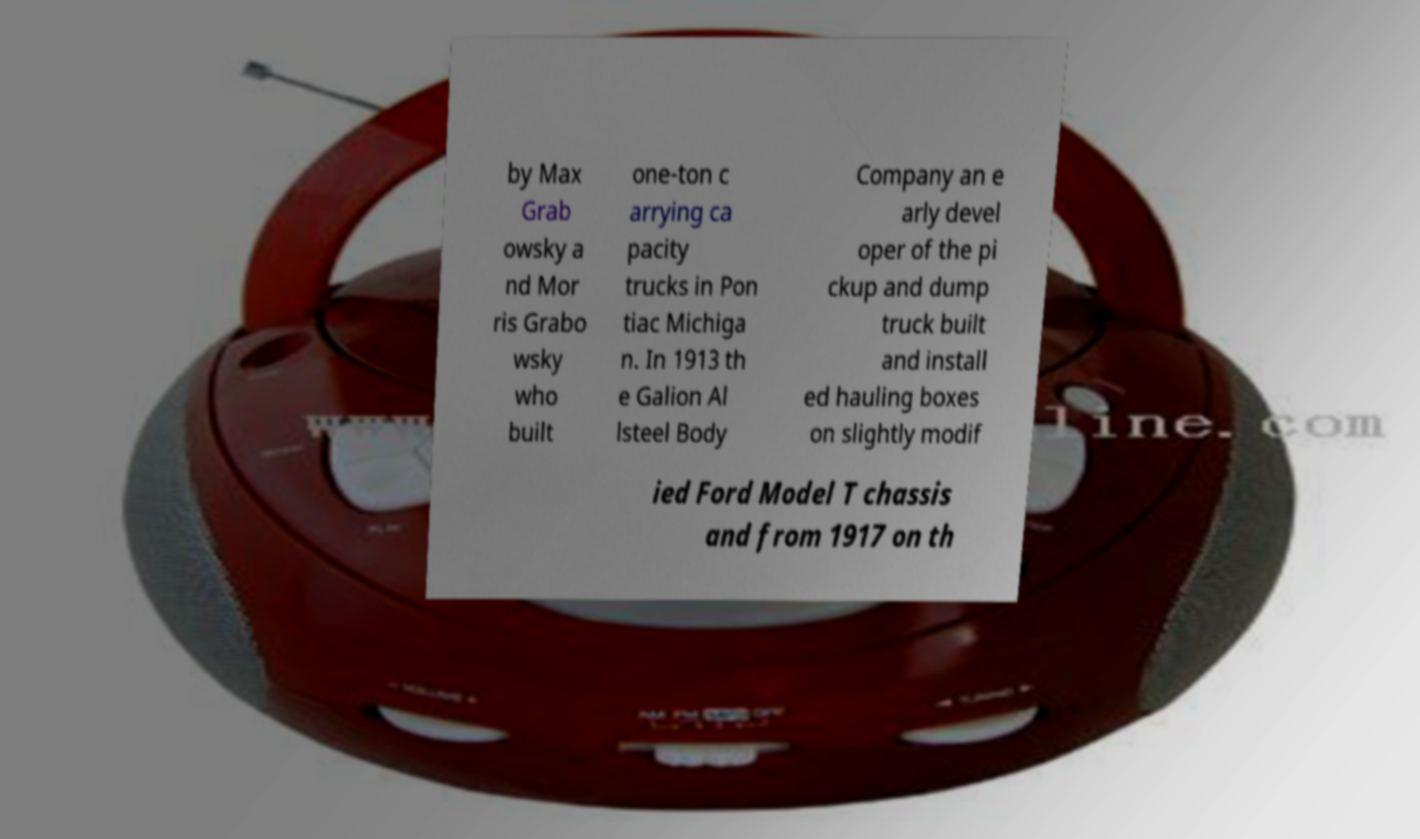What messages or text are displayed in this image? I need them in a readable, typed format. by Max Grab owsky a nd Mor ris Grabo wsky who built one-ton c arrying ca pacity trucks in Pon tiac Michiga n. In 1913 th e Galion Al lsteel Body Company an e arly devel oper of the pi ckup and dump truck built and install ed hauling boxes on slightly modif ied Ford Model T chassis and from 1917 on th 